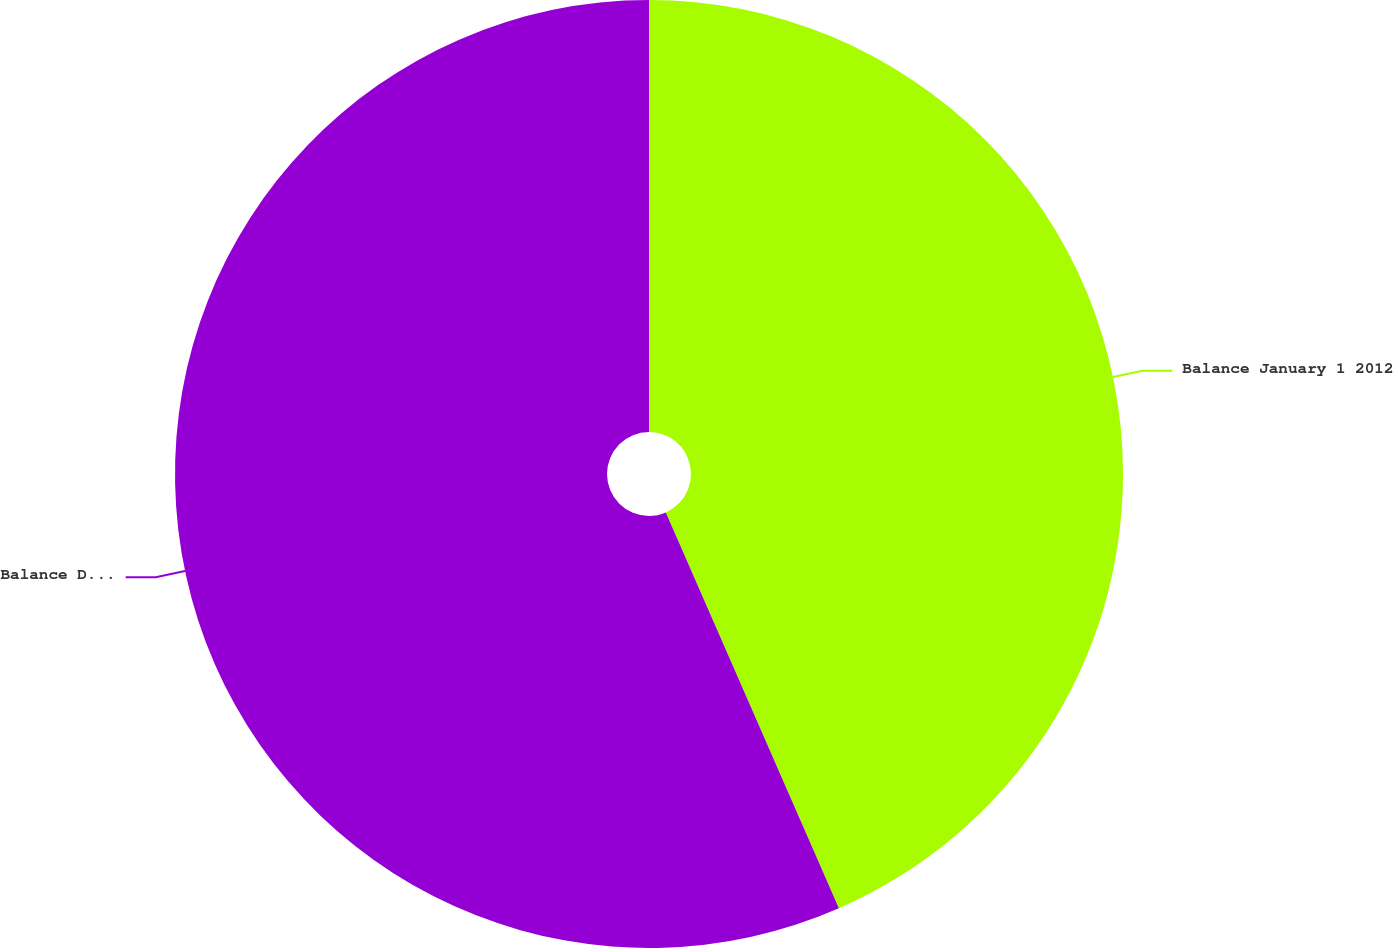<chart> <loc_0><loc_0><loc_500><loc_500><pie_chart><fcel>Balance January 1 2012<fcel>Balance December 31 2012<nl><fcel>43.44%<fcel>56.56%<nl></chart> 